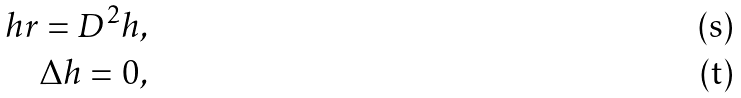<formula> <loc_0><loc_0><loc_500><loc_500>\ \quad h r = D ^ { 2 } h , \\ \Delta h = 0 ,</formula> 